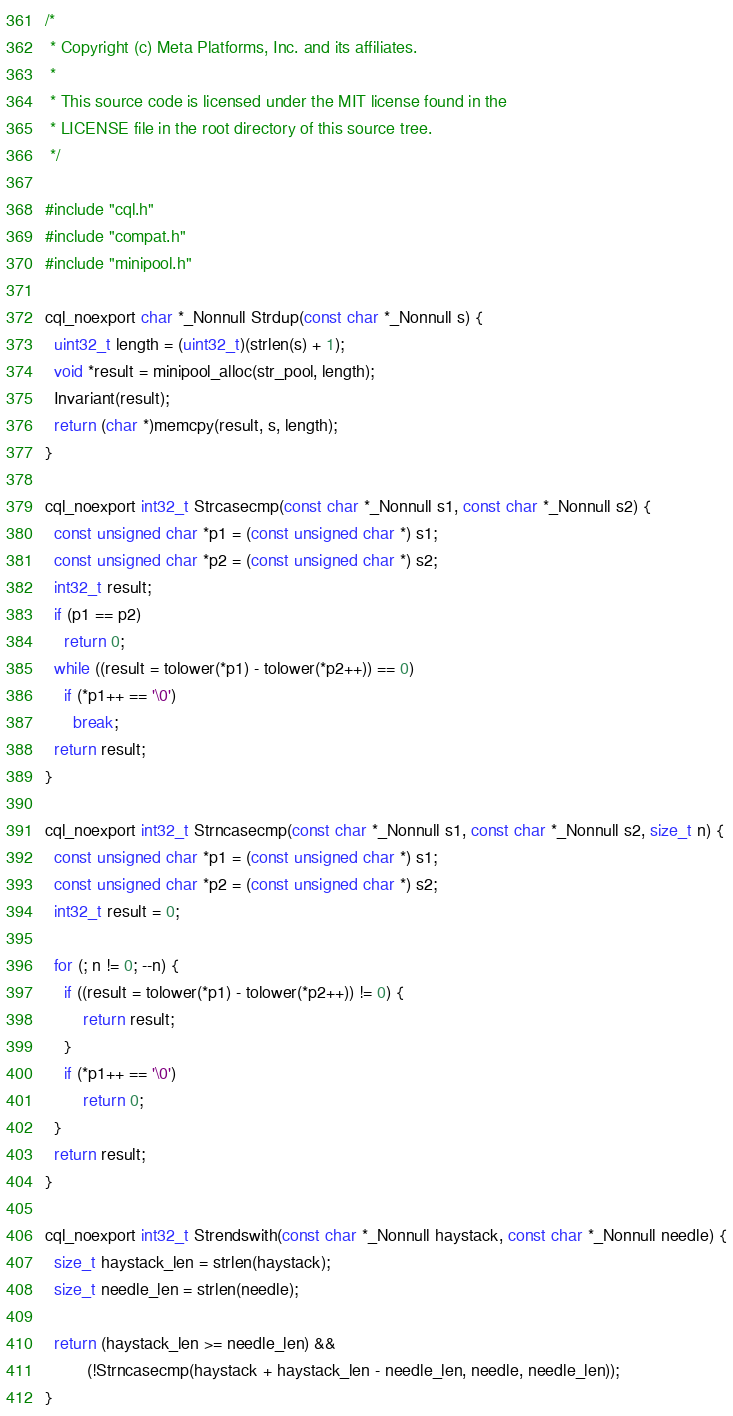<code> <loc_0><loc_0><loc_500><loc_500><_C_>/*
 * Copyright (c) Meta Platforms, Inc. and its affiliates.
 *
 * This source code is licensed under the MIT license found in the
 * LICENSE file in the root directory of this source tree.
 */

#include "cql.h"
#include "compat.h"
#include "minipool.h"

cql_noexport char *_Nonnull Strdup(const char *_Nonnull s) {
  uint32_t length = (uint32_t)(strlen(s) + 1);
  void *result = minipool_alloc(str_pool, length);
  Invariant(result);
  return (char *)memcpy(result, s, length);
}

cql_noexport int32_t Strcasecmp(const char *_Nonnull s1, const char *_Nonnull s2) {
  const unsigned char *p1 = (const unsigned char *) s1;
  const unsigned char *p2 = (const unsigned char *) s2;
  int32_t result;
  if (p1 == p2)
    return 0;
  while ((result = tolower(*p1) - tolower(*p2++)) == 0)
    if (*p1++ == '\0')
      break;
  return result;
}

cql_noexport int32_t Strncasecmp(const char *_Nonnull s1, const char *_Nonnull s2, size_t n) {
  const unsigned char *p1 = (const unsigned char *) s1;
  const unsigned char *p2 = (const unsigned char *) s2;
  int32_t result = 0;

  for (; n != 0; --n) {
    if ((result = tolower(*p1) - tolower(*p2++)) != 0) {
        return result;
    }
    if (*p1++ == '\0')
        return 0;
  }
  return result;
}

cql_noexport int32_t Strendswith(const char *_Nonnull haystack, const char *_Nonnull needle) {
  size_t haystack_len = strlen(haystack);
  size_t needle_len = strlen(needle);

  return (haystack_len >= needle_len) &&
         (!Strncasecmp(haystack + haystack_len - needle_len, needle, needle_len));
}
</code> 